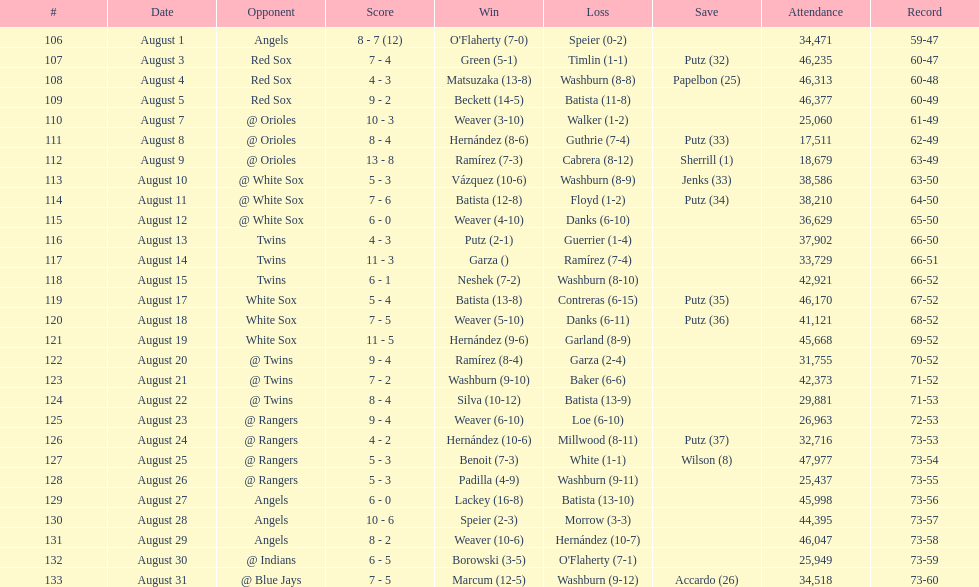Events exceeding 30,000 in audience size 21. 